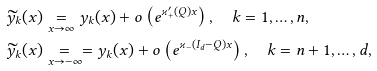Convert formula to latex. <formula><loc_0><loc_0><loc_500><loc_500>\widetilde { y } _ { k } ( x ) & \underset { x \to \infty } { = } y _ { k } ( x ) + o \left ( e ^ { \varkappa _ { + } ^ { \prime } ( Q ) x } \right ) , \quad k = 1 , \dots , n , \\ \widetilde { y } _ { k } ( x ) & \underset { x \to - \infty } { = } = y _ { k } ( x ) + o \left ( e ^ { \varkappa _ { - } ( I _ { d } - Q ) x } \right ) , \quad k = n + 1 , \dots , d ,</formula> 